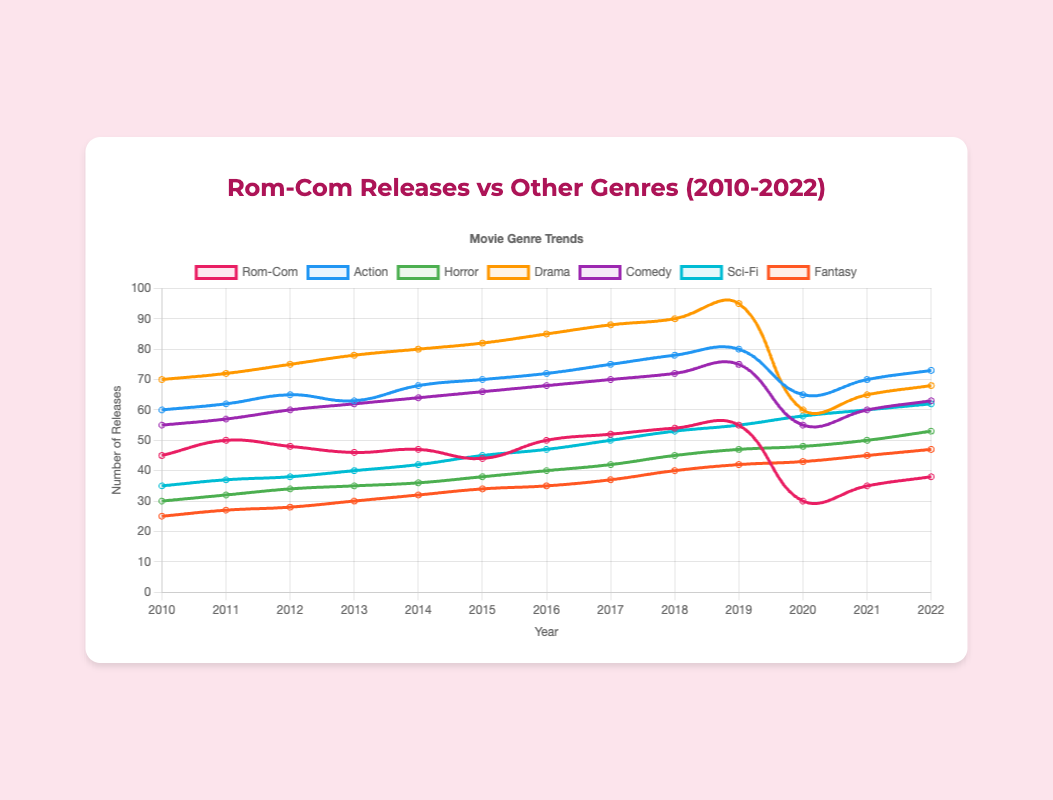How did the number of Rom-Com releases change from 2019 to 2020? In 2019, the number of Rom-Com releases was 55. In 2020, it dropped to 30. The difference is 55 - 30 = 25.
Answer: It decreased by 25 Which genre had the highest number of releases in 2015? By visually inspecting the chart for the highest peak in 2015, Drama appears to have the highest number of releases with 82.
Answer: Drama In which year did Rom-Com releases peak during the 2010-2022 period? The highest value in the Rom-Com line is 55 releases, which occurs in 2019.
Answer: 2019 Compare the trends for Rom-Com and Horror genres from 2010 to 2022. What is noticeable? Rom-Com releases fluctuated slightly before a sharp drop in 2020, then gradually increased. Horror releases steadily increased over the entire period.
Answer: Rom-Com fluctuated, then dropped, Horror steadily increased Summing up, how many Comedy releases were there during the 2010-2022 period? Summing the values for Comedy releases across all years: 55 + 57 + 60 + 62 + 64 + 66 + 68 + 70 + 72 + 75 + 55 + 60 + 63 = 827.
Answer: 827 Which year saw the maximum combined total releases for all genres? By inspecting each year and summing up the respective releases, 2019 has the highest combined total: 55 + 80 + 47 + 95 + 75 + 55 + 42 = 449.
Answer: 2019 In 2020, how does the number of Rom-Com releases compare to Fantasy releases? In 2020, there were 30 Rom-Com releases and 43 Fantasy releases. To compare, 30 < 43.
Answer: Rom-Com is less than Fantasy Which genre had the largest drop in releases from 2019 to 2020? Comparing the values of each genre between 2019 and 2020, Drama’s drop from 95 to 60 is the largest, with a difference of 35 releases.
Answer: Drama What is the average number of Sci-Fi releases between 2010 and 2022? Summing the Sci-Fi releases from 2010 to 2022 (35 + 37 + 38 + 40 + 42 + 45 + 47 + 50 + 53 + 55 + 58 + 60 + 62 = 622) and dividing by 13 years gives 622 / 13 = 47.85.
Answer: 47.85 